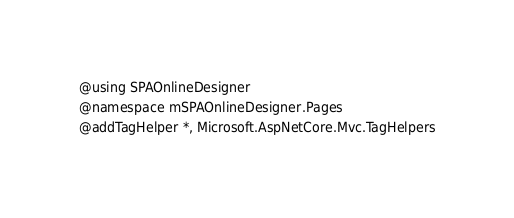Convert code to text. <code><loc_0><loc_0><loc_500><loc_500><_C#_>@using SPAOnlineDesigner
@namespace mSPAOnlineDesigner.Pages
@addTagHelper *, Microsoft.AspNetCore.Mvc.TagHelpers
</code> 